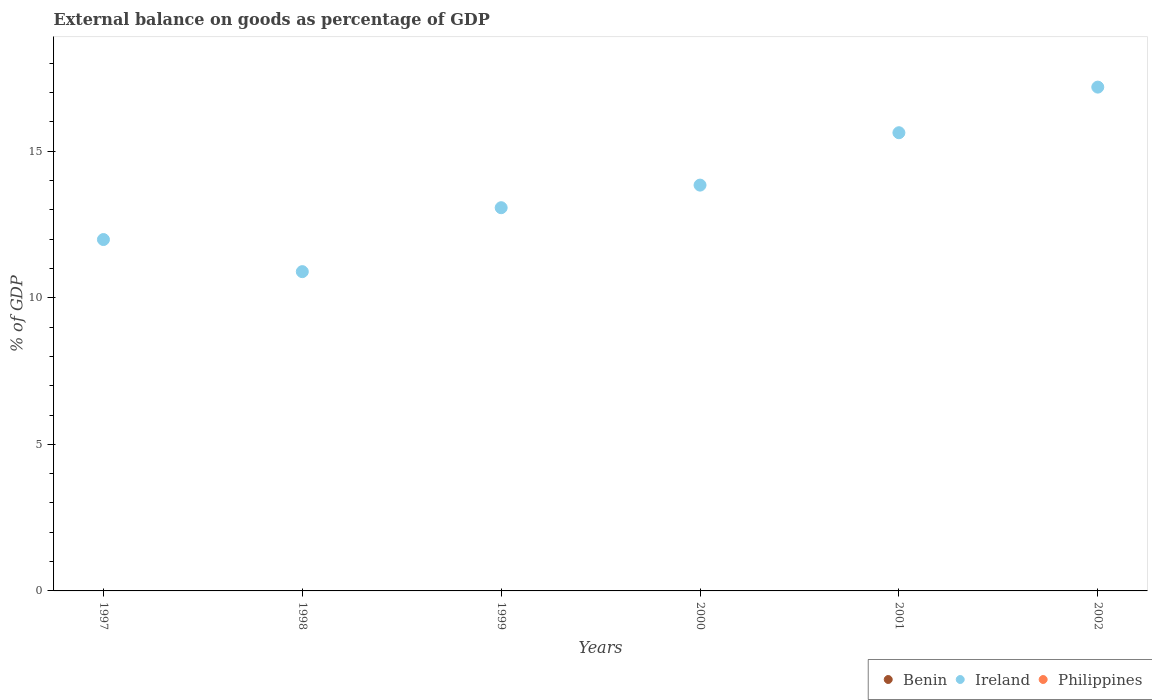How many different coloured dotlines are there?
Keep it short and to the point. 1. Is the number of dotlines equal to the number of legend labels?
Provide a succinct answer. No. Across all years, what is the maximum external balance on goods as percentage of GDP in Ireland?
Provide a short and direct response. 17.19. Across all years, what is the minimum external balance on goods as percentage of GDP in Philippines?
Make the answer very short. 0. In which year was the external balance on goods as percentage of GDP in Ireland maximum?
Provide a short and direct response. 2002. What is the difference between the external balance on goods as percentage of GDP in Ireland in 1997 and that in 2002?
Your answer should be very brief. -5.2. What is the difference between the external balance on goods as percentage of GDP in Philippines in 1997 and the external balance on goods as percentage of GDP in Benin in 2000?
Your answer should be compact. 0. In how many years, is the external balance on goods as percentage of GDP in Philippines greater than 2 %?
Give a very brief answer. 0. What is the difference between the highest and the lowest external balance on goods as percentage of GDP in Ireland?
Ensure brevity in your answer.  6.29. Is it the case that in every year, the sum of the external balance on goods as percentage of GDP in Benin and external balance on goods as percentage of GDP in Ireland  is greater than the external balance on goods as percentage of GDP in Philippines?
Ensure brevity in your answer.  Yes. Does the external balance on goods as percentage of GDP in Ireland monotonically increase over the years?
Provide a short and direct response. No. Is the external balance on goods as percentage of GDP in Philippines strictly greater than the external balance on goods as percentage of GDP in Ireland over the years?
Ensure brevity in your answer.  No. How many dotlines are there?
Give a very brief answer. 1. How many years are there in the graph?
Give a very brief answer. 6. Does the graph contain grids?
Keep it short and to the point. No. Where does the legend appear in the graph?
Your answer should be compact. Bottom right. How many legend labels are there?
Give a very brief answer. 3. How are the legend labels stacked?
Offer a very short reply. Horizontal. What is the title of the graph?
Your answer should be very brief. External balance on goods as percentage of GDP. What is the label or title of the X-axis?
Keep it short and to the point. Years. What is the label or title of the Y-axis?
Keep it short and to the point. % of GDP. What is the % of GDP of Ireland in 1997?
Offer a very short reply. 11.99. What is the % of GDP in Philippines in 1997?
Offer a very short reply. 0. What is the % of GDP in Ireland in 1998?
Your response must be concise. 10.89. What is the % of GDP of Philippines in 1998?
Provide a short and direct response. 0. What is the % of GDP of Benin in 1999?
Give a very brief answer. 0. What is the % of GDP of Ireland in 1999?
Your answer should be very brief. 13.07. What is the % of GDP of Philippines in 1999?
Provide a succinct answer. 0. What is the % of GDP of Benin in 2000?
Provide a short and direct response. 0. What is the % of GDP of Ireland in 2000?
Ensure brevity in your answer.  13.84. What is the % of GDP of Benin in 2001?
Make the answer very short. 0. What is the % of GDP of Ireland in 2001?
Provide a succinct answer. 15.63. What is the % of GDP in Ireland in 2002?
Provide a succinct answer. 17.19. What is the % of GDP of Philippines in 2002?
Provide a succinct answer. 0. Across all years, what is the maximum % of GDP in Ireland?
Give a very brief answer. 17.19. Across all years, what is the minimum % of GDP in Ireland?
Your answer should be very brief. 10.89. What is the total % of GDP in Ireland in the graph?
Your response must be concise. 82.61. What is the difference between the % of GDP of Ireland in 1997 and that in 1998?
Your answer should be compact. 1.1. What is the difference between the % of GDP of Ireland in 1997 and that in 1999?
Offer a very short reply. -1.09. What is the difference between the % of GDP in Ireland in 1997 and that in 2000?
Your answer should be very brief. -1.86. What is the difference between the % of GDP of Ireland in 1997 and that in 2001?
Offer a very short reply. -3.64. What is the difference between the % of GDP of Ireland in 1997 and that in 2002?
Provide a succinct answer. -5.2. What is the difference between the % of GDP of Ireland in 1998 and that in 1999?
Give a very brief answer. -2.18. What is the difference between the % of GDP in Ireland in 1998 and that in 2000?
Keep it short and to the point. -2.95. What is the difference between the % of GDP of Ireland in 1998 and that in 2001?
Your response must be concise. -4.74. What is the difference between the % of GDP of Ireland in 1998 and that in 2002?
Offer a terse response. -6.29. What is the difference between the % of GDP of Ireland in 1999 and that in 2000?
Provide a succinct answer. -0.77. What is the difference between the % of GDP in Ireland in 1999 and that in 2001?
Provide a succinct answer. -2.56. What is the difference between the % of GDP in Ireland in 1999 and that in 2002?
Offer a very short reply. -4.11. What is the difference between the % of GDP in Ireland in 2000 and that in 2001?
Your response must be concise. -1.79. What is the difference between the % of GDP of Ireland in 2000 and that in 2002?
Your answer should be compact. -3.34. What is the difference between the % of GDP of Ireland in 2001 and that in 2002?
Offer a very short reply. -1.56. What is the average % of GDP in Benin per year?
Your answer should be compact. 0. What is the average % of GDP in Ireland per year?
Provide a short and direct response. 13.77. What is the ratio of the % of GDP of Ireland in 1997 to that in 1998?
Give a very brief answer. 1.1. What is the ratio of the % of GDP in Ireland in 1997 to that in 1999?
Offer a very short reply. 0.92. What is the ratio of the % of GDP in Ireland in 1997 to that in 2000?
Your answer should be very brief. 0.87. What is the ratio of the % of GDP in Ireland in 1997 to that in 2001?
Give a very brief answer. 0.77. What is the ratio of the % of GDP in Ireland in 1997 to that in 2002?
Ensure brevity in your answer.  0.7. What is the ratio of the % of GDP in Ireland in 1998 to that in 1999?
Your answer should be very brief. 0.83. What is the ratio of the % of GDP in Ireland in 1998 to that in 2000?
Keep it short and to the point. 0.79. What is the ratio of the % of GDP in Ireland in 1998 to that in 2001?
Offer a terse response. 0.7. What is the ratio of the % of GDP of Ireland in 1998 to that in 2002?
Your answer should be very brief. 0.63. What is the ratio of the % of GDP in Ireland in 1999 to that in 2000?
Make the answer very short. 0.94. What is the ratio of the % of GDP of Ireland in 1999 to that in 2001?
Offer a very short reply. 0.84. What is the ratio of the % of GDP of Ireland in 1999 to that in 2002?
Offer a very short reply. 0.76. What is the ratio of the % of GDP of Ireland in 2000 to that in 2001?
Ensure brevity in your answer.  0.89. What is the ratio of the % of GDP of Ireland in 2000 to that in 2002?
Make the answer very short. 0.81. What is the ratio of the % of GDP in Ireland in 2001 to that in 2002?
Provide a succinct answer. 0.91. What is the difference between the highest and the second highest % of GDP of Ireland?
Keep it short and to the point. 1.56. What is the difference between the highest and the lowest % of GDP of Ireland?
Provide a succinct answer. 6.29. 